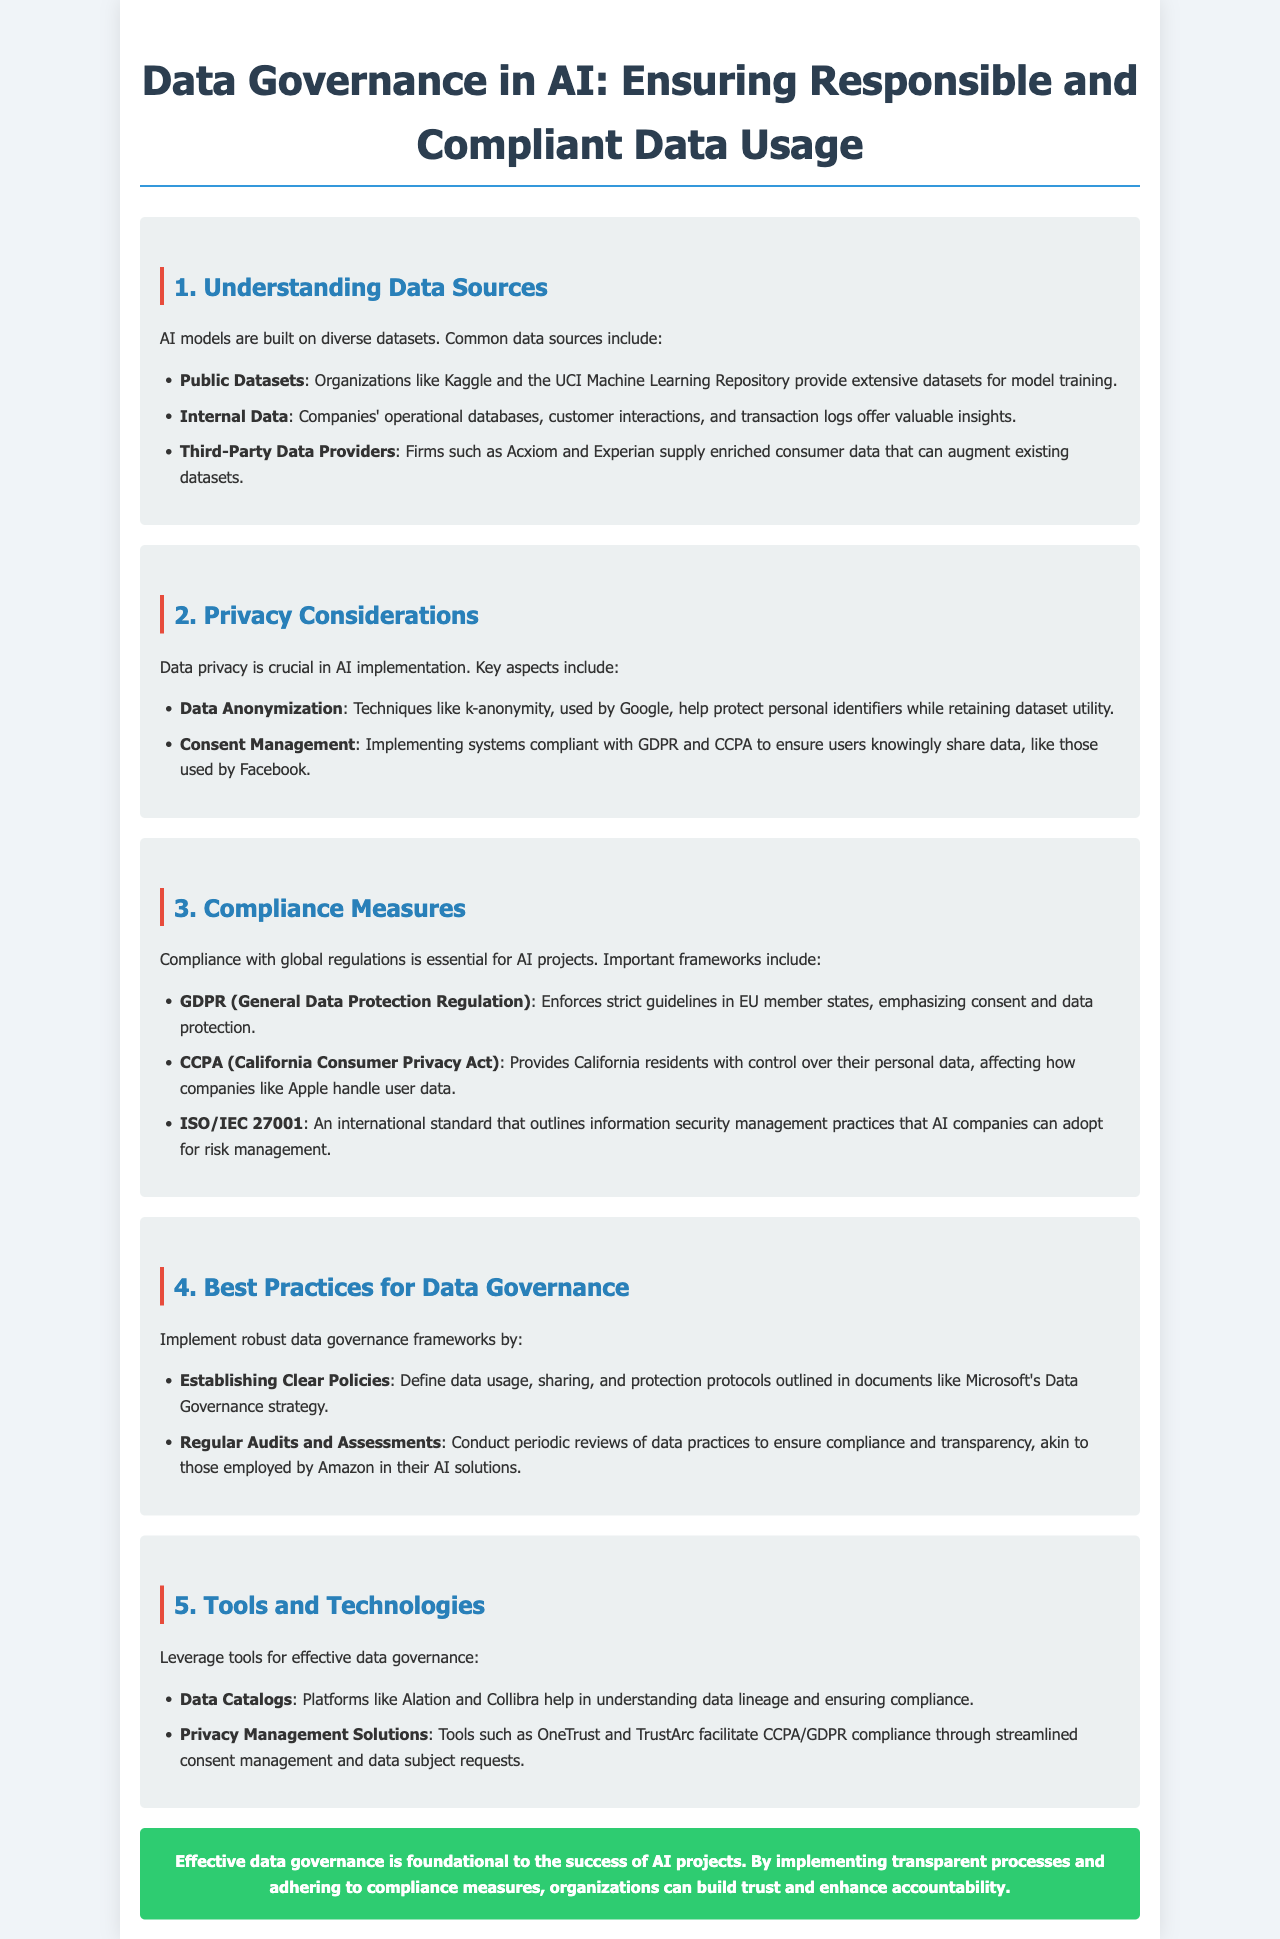What are the three common data sources mentioned? The document lists three common data sources which are public datasets, internal data, and third-party data providers.
Answer: public datasets, internal data, third-party data providers What is the purpose of data anonymization? The document states that data anonymization techniques protect personal identifiers while retaining dataset utility.
Answer: Protect personal identifiers What regulation emphasizes consent and data protection? The document specifies GDPR, which enforces strict guidelines in EU member states, emphasizing consent and data protection.
Answer: GDPR What is one example of a privacy management solution mentioned? The document refers to OneTrust and TrustArc as examples of privacy management solutions that facilitate compliance.
Answer: OneTrust Which regulatory framework gives control over personal data to California residents? The document mentions CCPA, which provides California residents with control over their personal data.
Answer: CCPA What is a key aspect of consent management? The document highlights that consent management involves implementing systems compliant with GDPR and CCPA.
Answer: Compliant systems What is a best practice for data governance mentioned? The document states that establishing clear policies is a best practice for data governance.
Answer: Establishing clear policies Name a tool that helps in understanding data lineage. The document lists data catalogs, such as Alation and Collibra, which help in understanding data lineage.
Answer: Data catalogs What is the main conclusion about data governance in AI projects? The document concludes that effective data governance is foundational to the success of AI projects.
Answer: Foundational to success 